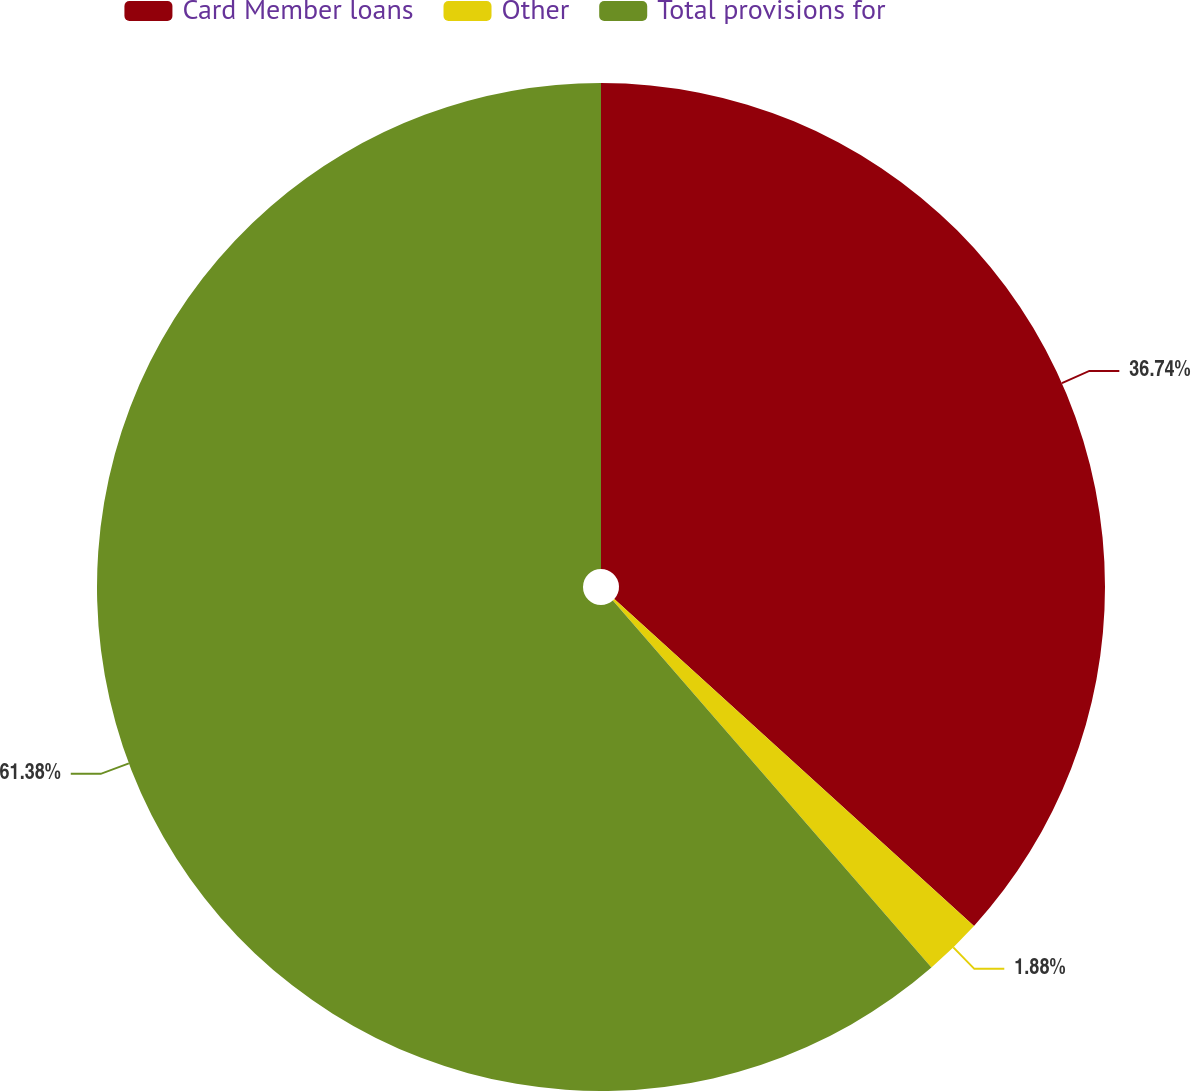<chart> <loc_0><loc_0><loc_500><loc_500><pie_chart><fcel>Card Member loans<fcel>Other<fcel>Total provisions for<nl><fcel>36.74%<fcel>1.88%<fcel>61.38%<nl></chart> 